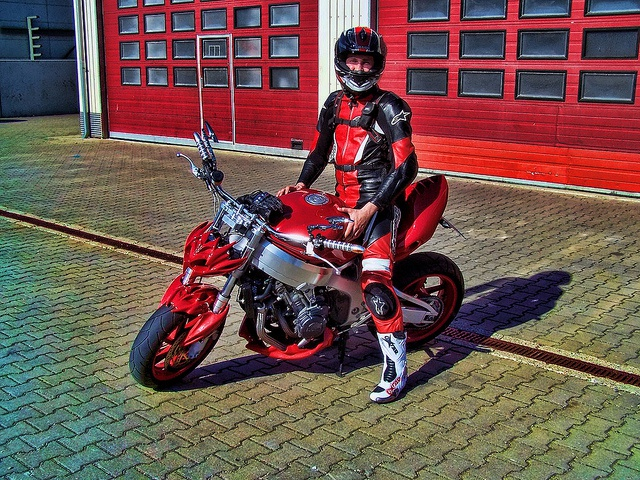Describe the objects in this image and their specific colors. I can see motorcycle in darkblue, black, maroon, gray, and brown tones and people in darkblue, black, red, maroon, and lavender tones in this image. 